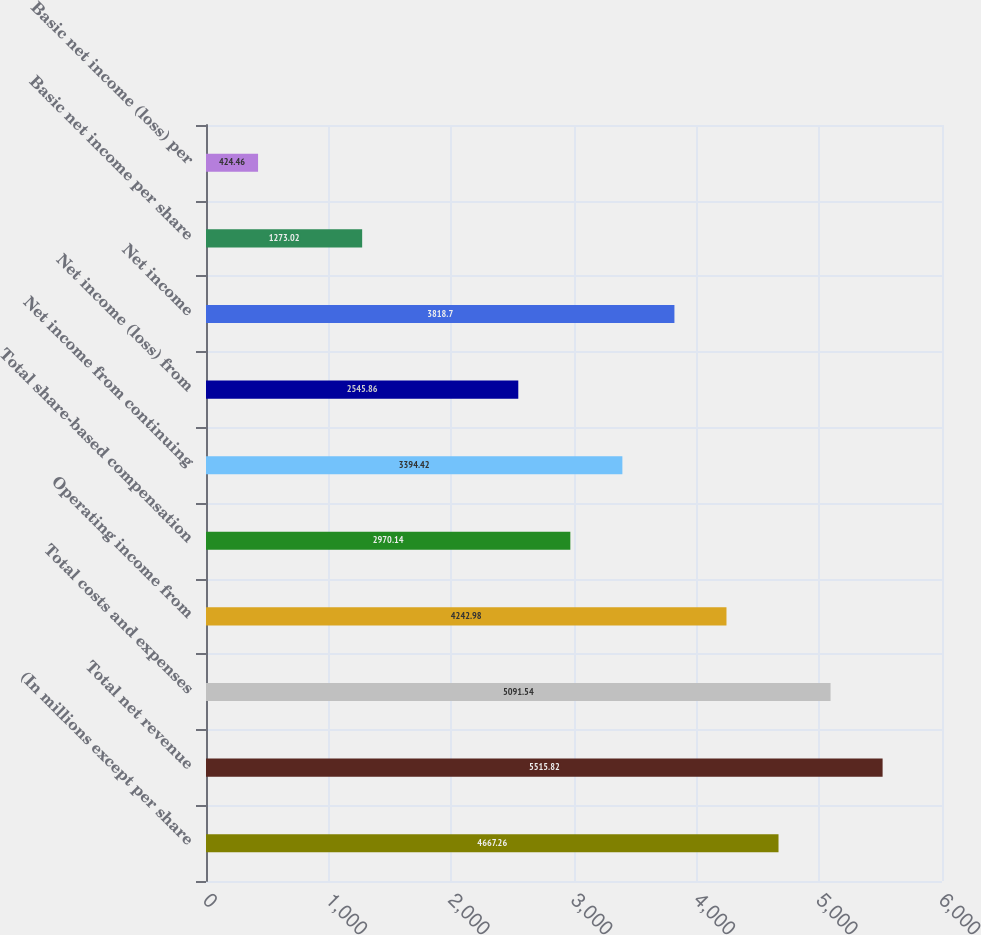<chart> <loc_0><loc_0><loc_500><loc_500><bar_chart><fcel>(In millions except per share<fcel>Total net revenue<fcel>Total costs and expenses<fcel>Operating income from<fcel>Total share-based compensation<fcel>Net income from continuing<fcel>Net income (loss) from<fcel>Net income<fcel>Basic net income per share<fcel>Basic net income (loss) per<nl><fcel>4667.26<fcel>5515.82<fcel>5091.54<fcel>4242.98<fcel>2970.14<fcel>3394.42<fcel>2545.86<fcel>3818.7<fcel>1273.02<fcel>424.46<nl></chart> 